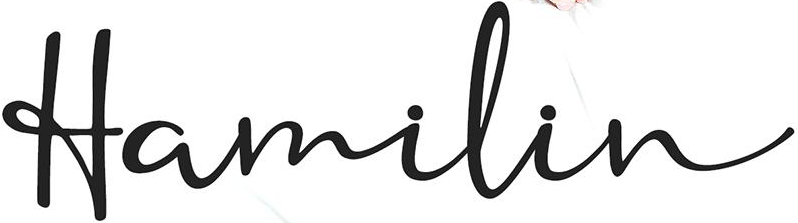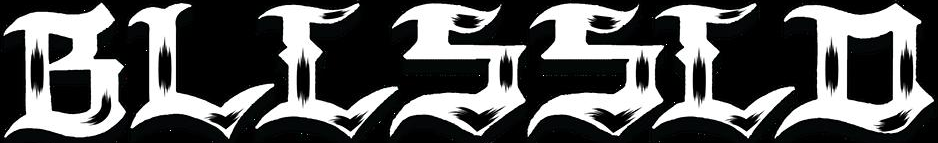Transcribe the words shown in these images in order, separated by a semicolon. Hamilin; BLLSSLD 